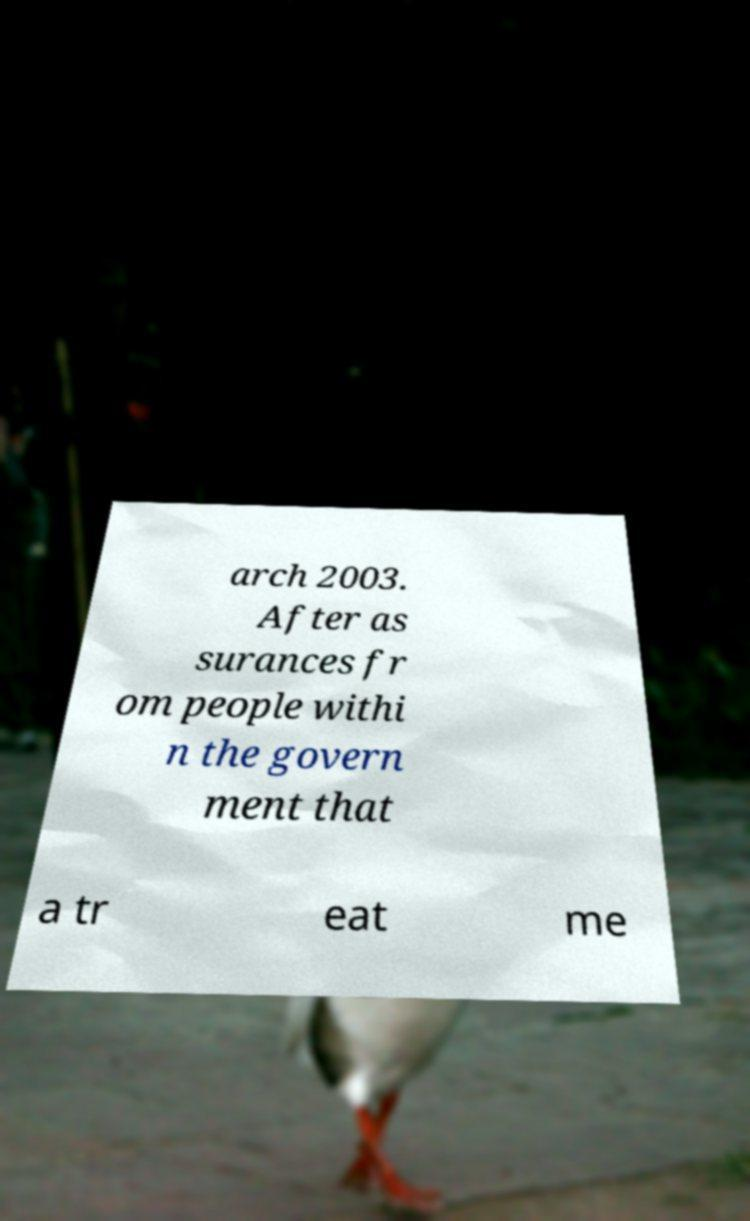Can you accurately transcribe the text from the provided image for me? arch 2003. After as surances fr om people withi n the govern ment that a tr eat me 